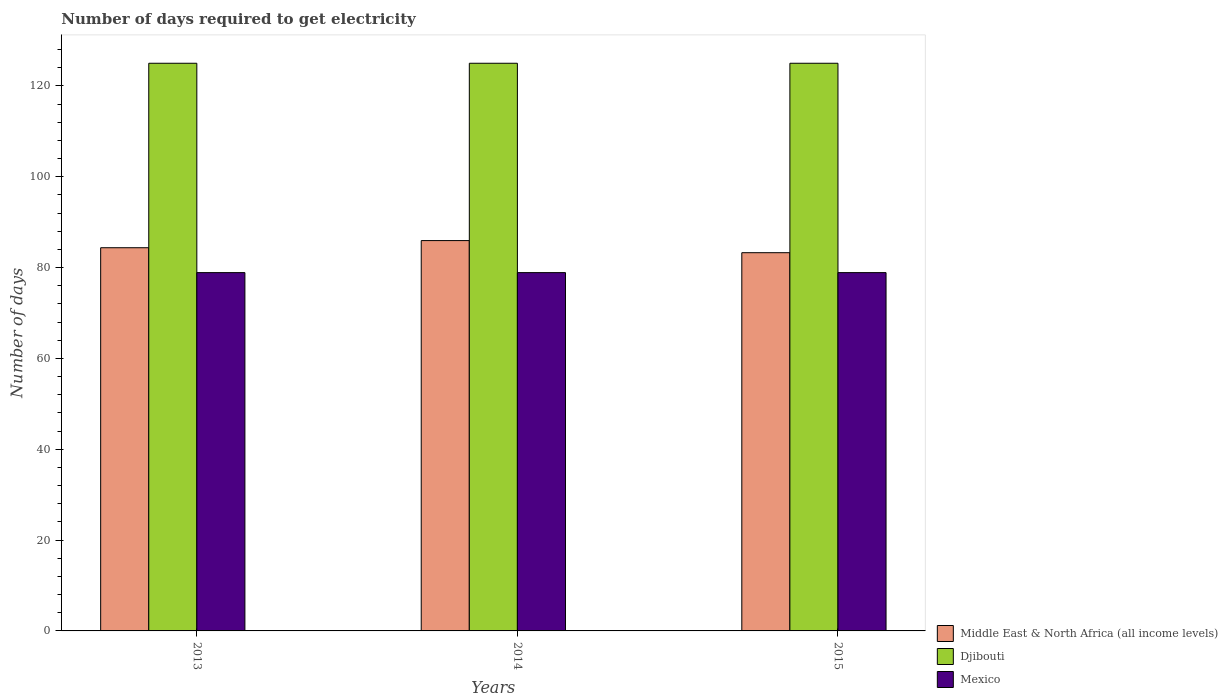How many different coloured bars are there?
Keep it short and to the point. 3. How many groups of bars are there?
Offer a terse response. 3. Are the number of bars per tick equal to the number of legend labels?
Provide a short and direct response. Yes. What is the label of the 1st group of bars from the left?
Make the answer very short. 2013. In how many cases, is the number of bars for a given year not equal to the number of legend labels?
Keep it short and to the point. 0. What is the number of days required to get electricity in in Middle East & North Africa (all income levels) in 2013?
Ensure brevity in your answer.  84.38. Across all years, what is the maximum number of days required to get electricity in in Mexico?
Keep it short and to the point. 78.9. Across all years, what is the minimum number of days required to get electricity in in Djibouti?
Your answer should be very brief. 125. What is the total number of days required to get electricity in in Middle East & North Africa (all income levels) in the graph?
Give a very brief answer. 253.62. What is the difference between the number of days required to get electricity in in Mexico in 2014 and that in 2015?
Offer a terse response. 0. What is the difference between the number of days required to get electricity in in Djibouti in 2015 and the number of days required to get electricity in in Mexico in 2014?
Give a very brief answer. 46.1. What is the average number of days required to get electricity in in Mexico per year?
Ensure brevity in your answer.  78.9. In the year 2015, what is the difference between the number of days required to get electricity in in Mexico and number of days required to get electricity in in Djibouti?
Ensure brevity in your answer.  -46.1. In how many years, is the number of days required to get electricity in in Middle East & North Africa (all income levels) greater than 8 days?
Your response must be concise. 3. What is the ratio of the number of days required to get electricity in in Middle East & North Africa (all income levels) in 2013 to that in 2014?
Your answer should be very brief. 0.98. Is the number of days required to get electricity in in Middle East & North Africa (all income levels) in 2013 less than that in 2015?
Make the answer very short. No. Is the difference between the number of days required to get electricity in in Mexico in 2013 and 2014 greater than the difference between the number of days required to get electricity in in Djibouti in 2013 and 2014?
Offer a terse response. No. What is the difference between the highest and the second highest number of days required to get electricity in in Mexico?
Make the answer very short. 0. What is the difference between the highest and the lowest number of days required to get electricity in in Middle East & North Africa (all income levels)?
Your answer should be very brief. 2.67. In how many years, is the number of days required to get electricity in in Mexico greater than the average number of days required to get electricity in in Mexico taken over all years?
Your response must be concise. 0. Is the sum of the number of days required to get electricity in in Mexico in 2014 and 2015 greater than the maximum number of days required to get electricity in in Djibouti across all years?
Provide a short and direct response. Yes. What does the 1st bar from the left in 2015 represents?
Offer a terse response. Middle East & North Africa (all income levels). What does the 2nd bar from the right in 2013 represents?
Ensure brevity in your answer.  Djibouti. Is it the case that in every year, the sum of the number of days required to get electricity in in Djibouti and number of days required to get electricity in in Mexico is greater than the number of days required to get electricity in in Middle East & North Africa (all income levels)?
Provide a short and direct response. Yes. How many bars are there?
Make the answer very short. 9. Are all the bars in the graph horizontal?
Offer a terse response. No. How many years are there in the graph?
Offer a terse response. 3. Where does the legend appear in the graph?
Offer a very short reply. Bottom right. What is the title of the graph?
Give a very brief answer. Number of days required to get electricity. What is the label or title of the X-axis?
Offer a terse response. Years. What is the label or title of the Y-axis?
Provide a succinct answer. Number of days. What is the Number of days in Middle East & North Africa (all income levels) in 2013?
Keep it short and to the point. 84.38. What is the Number of days in Djibouti in 2013?
Keep it short and to the point. 125. What is the Number of days of Mexico in 2013?
Offer a very short reply. 78.9. What is the Number of days in Middle East & North Africa (all income levels) in 2014?
Offer a terse response. 85.95. What is the Number of days of Djibouti in 2014?
Offer a very short reply. 125. What is the Number of days in Mexico in 2014?
Make the answer very short. 78.9. What is the Number of days of Middle East & North Africa (all income levels) in 2015?
Give a very brief answer. 83.29. What is the Number of days of Djibouti in 2015?
Give a very brief answer. 125. What is the Number of days of Mexico in 2015?
Provide a short and direct response. 78.9. Across all years, what is the maximum Number of days in Middle East & North Africa (all income levels)?
Offer a terse response. 85.95. Across all years, what is the maximum Number of days in Djibouti?
Keep it short and to the point. 125. Across all years, what is the maximum Number of days of Mexico?
Your response must be concise. 78.9. Across all years, what is the minimum Number of days of Middle East & North Africa (all income levels)?
Your response must be concise. 83.29. Across all years, what is the minimum Number of days in Djibouti?
Offer a very short reply. 125. Across all years, what is the minimum Number of days of Mexico?
Provide a short and direct response. 78.9. What is the total Number of days in Middle East & North Africa (all income levels) in the graph?
Keep it short and to the point. 253.62. What is the total Number of days of Djibouti in the graph?
Keep it short and to the point. 375. What is the total Number of days of Mexico in the graph?
Make the answer very short. 236.7. What is the difference between the Number of days in Middle East & North Africa (all income levels) in 2013 and that in 2014?
Your answer should be very brief. -1.57. What is the difference between the Number of days in Djibouti in 2013 and that in 2014?
Provide a succinct answer. 0. What is the difference between the Number of days in Middle East & North Africa (all income levels) in 2013 and that in 2015?
Make the answer very short. 1.1. What is the difference between the Number of days of Djibouti in 2013 and that in 2015?
Keep it short and to the point. 0. What is the difference between the Number of days of Middle East & North Africa (all income levels) in 2014 and that in 2015?
Offer a terse response. 2.67. What is the difference between the Number of days of Mexico in 2014 and that in 2015?
Offer a very short reply. 0. What is the difference between the Number of days of Middle East & North Africa (all income levels) in 2013 and the Number of days of Djibouti in 2014?
Your answer should be compact. -40.62. What is the difference between the Number of days of Middle East & North Africa (all income levels) in 2013 and the Number of days of Mexico in 2014?
Give a very brief answer. 5.48. What is the difference between the Number of days of Djibouti in 2013 and the Number of days of Mexico in 2014?
Make the answer very short. 46.1. What is the difference between the Number of days of Middle East & North Africa (all income levels) in 2013 and the Number of days of Djibouti in 2015?
Give a very brief answer. -40.62. What is the difference between the Number of days of Middle East & North Africa (all income levels) in 2013 and the Number of days of Mexico in 2015?
Provide a succinct answer. 5.48. What is the difference between the Number of days in Djibouti in 2013 and the Number of days in Mexico in 2015?
Your answer should be compact. 46.1. What is the difference between the Number of days in Middle East & North Africa (all income levels) in 2014 and the Number of days in Djibouti in 2015?
Your answer should be compact. -39.05. What is the difference between the Number of days of Middle East & North Africa (all income levels) in 2014 and the Number of days of Mexico in 2015?
Keep it short and to the point. 7.05. What is the difference between the Number of days in Djibouti in 2014 and the Number of days in Mexico in 2015?
Your answer should be very brief. 46.1. What is the average Number of days of Middle East & North Africa (all income levels) per year?
Provide a short and direct response. 84.54. What is the average Number of days of Djibouti per year?
Ensure brevity in your answer.  125. What is the average Number of days in Mexico per year?
Keep it short and to the point. 78.9. In the year 2013, what is the difference between the Number of days of Middle East & North Africa (all income levels) and Number of days of Djibouti?
Keep it short and to the point. -40.62. In the year 2013, what is the difference between the Number of days of Middle East & North Africa (all income levels) and Number of days of Mexico?
Make the answer very short. 5.48. In the year 2013, what is the difference between the Number of days of Djibouti and Number of days of Mexico?
Your answer should be very brief. 46.1. In the year 2014, what is the difference between the Number of days in Middle East & North Africa (all income levels) and Number of days in Djibouti?
Give a very brief answer. -39.05. In the year 2014, what is the difference between the Number of days of Middle East & North Africa (all income levels) and Number of days of Mexico?
Your answer should be very brief. 7.05. In the year 2014, what is the difference between the Number of days of Djibouti and Number of days of Mexico?
Your answer should be very brief. 46.1. In the year 2015, what is the difference between the Number of days of Middle East & North Africa (all income levels) and Number of days of Djibouti?
Your answer should be compact. -41.71. In the year 2015, what is the difference between the Number of days of Middle East & North Africa (all income levels) and Number of days of Mexico?
Provide a succinct answer. 4.39. In the year 2015, what is the difference between the Number of days of Djibouti and Number of days of Mexico?
Your answer should be compact. 46.1. What is the ratio of the Number of days in Middle East & North Africa (all income levels) in 2013 to that in 2014?
Offer a very short reply. 0.98. What is the ratio of the Number of days of Djibouti in 2013 to that in 2014?
Make the answer very short. 1. What is the ratio of the Number of days in Mexico in 2013 to that in 2014?
Your answer should be compact. 1. What is the ratio of the Number of days of Middle East & North Africa (all income levels) in 2013 to that in 2015?
Your answer should be very brief. 1.01. What is the ratio of the Number of days in Mexico in 2013 to that in 2015?
Your answer should be very brief. 1. What is the ratio of the Number of days in Middle East & North Africa (all income levels) in 2014 to that in 2015?
Provide a succinct answer. 1.03. What is the ratio of the Number of days in Mexico in 2014 to that in 2015?
Offer a very short reply. 1. What is the difference between the highest and the second highest Number of days of Middle East & North Africa (all income levels)?
Ensure brevity in your answer.  1.57. What is the difference between the highest and the lowest Number of days of Middle East & North Africa (all income levels)?
Your answer should be very brief. 2.67. 